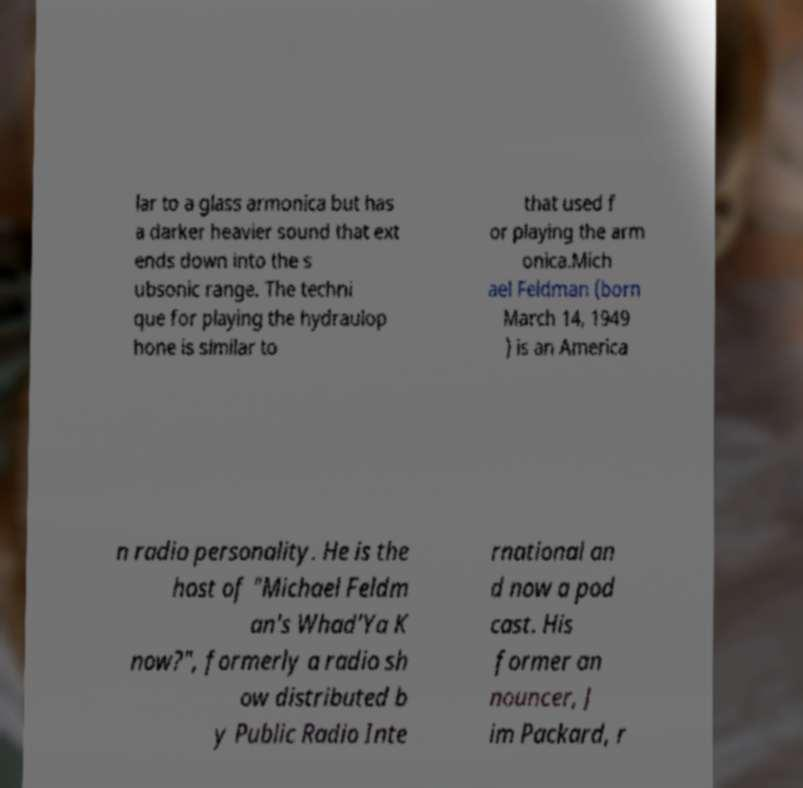Could you assist in decoding the text presented in this image and type it out clearly? lar to a glass armonica but has a darker heavier sound that ext ends down into the s ubsonic range. The techni que for playing the hydraulop hone is similar to that used f or playing the arm onica.Mich ael Feldman (born March 14, 1949 ) is an America n radio personality. He is the host of "Michael Feldm an's Whad'Ya K now?", formerly a radio sh ow distributed b y Public Radio Inte rnational an d now a pod cast. His former an nouncer, J im Packard, r 